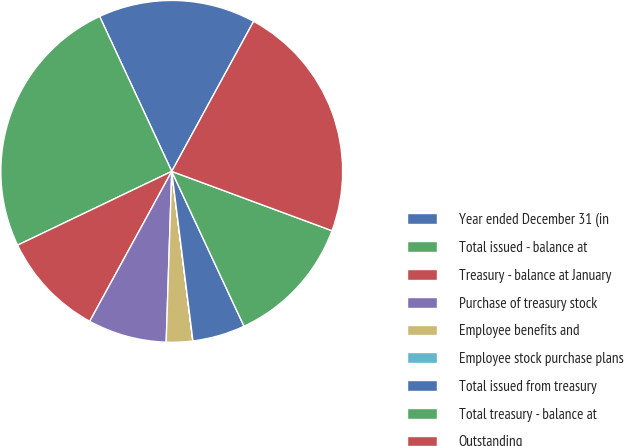<chart> <loc_0><loc_0><loc_500><loc_500><pie_chart><fcel>Year ended December 31 (in<fcel>Total issued - balance at<fcel>Treasury - balance at January<fcel>Purchase of treasury stock<fcel>Employee benefits and<fcel>Employee stock purchase plans<fcel>Total issued from treasury<fcel>Total treasury - balance at<fcel>Outstanding<nl><fcel>14.89%<fcel>25.18%<fcel>9.93%<fcel>7.45%<fcel>2.49%<fcel>0.01%<fcel>4.97%<fcel>12.41%<fcel>22.7%<nl></chart> 